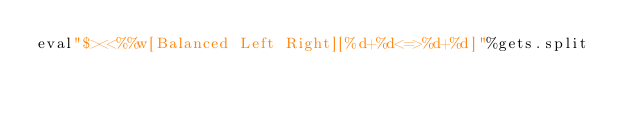<code> <loc_0><loc_0><loc_500><loc_500><_Ruby_>eval"$><<%%w[Balanced Left Right][%d+%d<=>%d+%d]"%gets.split</code> 